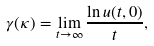<formula> <loc_0><loc_0><loc_500><loc_500>\gamma ( \kappa ) = \lim _ { t \rightarrow \infty } \frac { \ln u ( t , 0 ) } { t } ,</formula> 